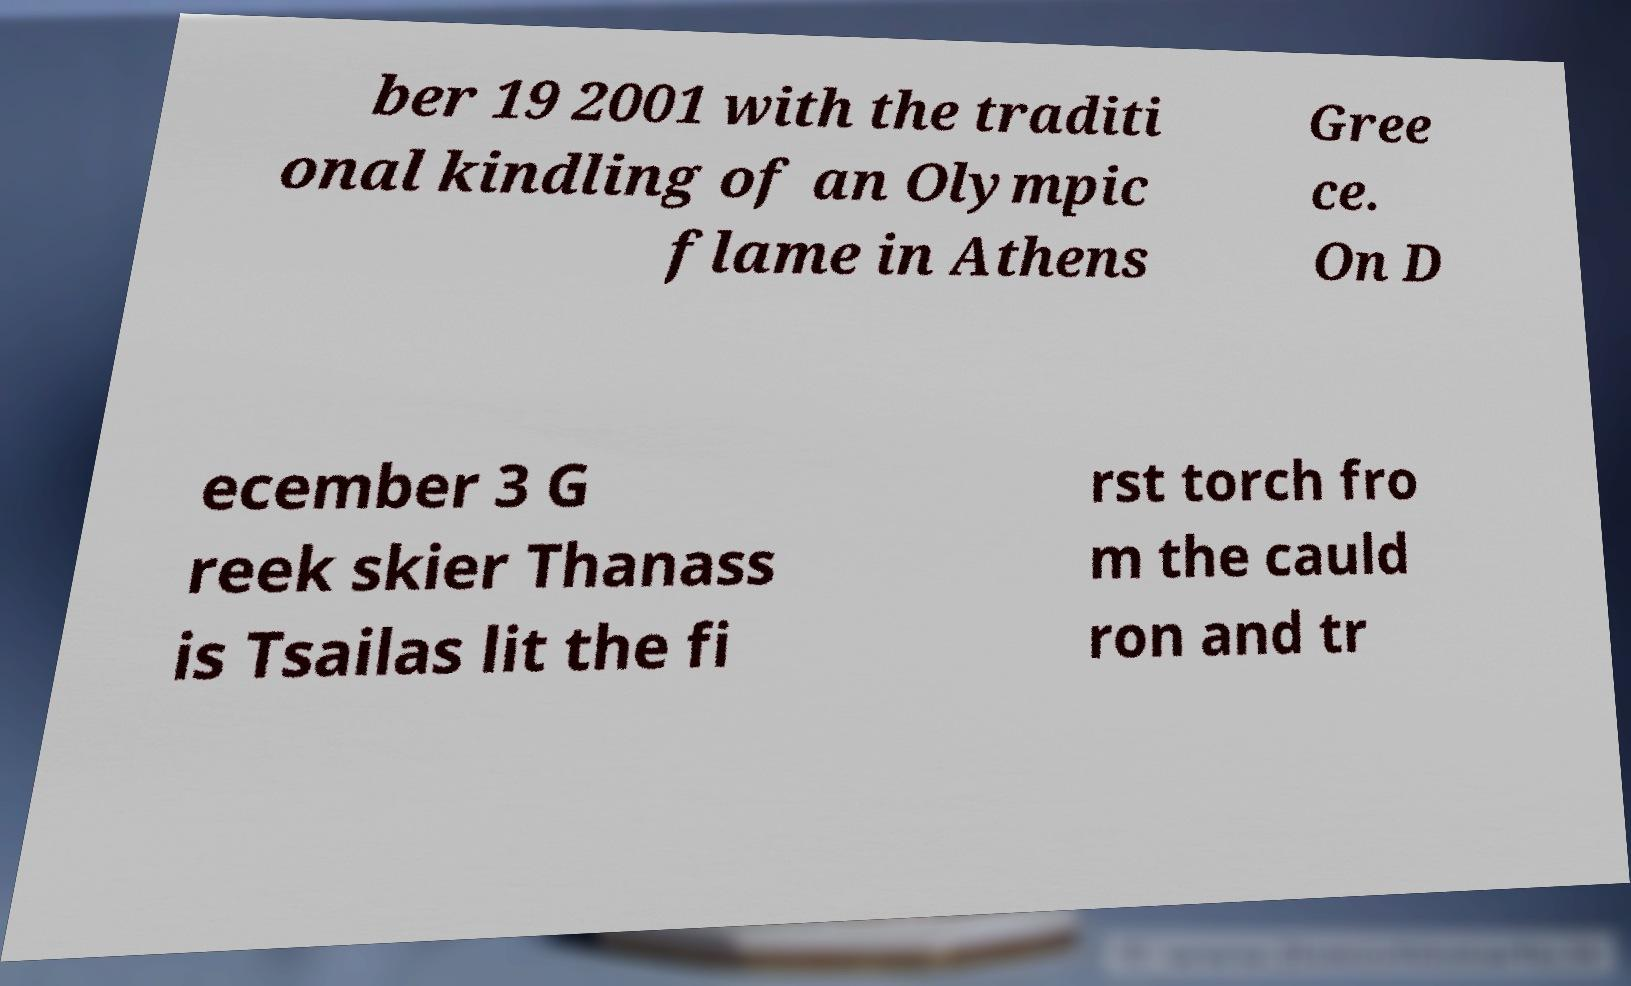For documentation purposes, I need the text within this image transcribed. Could you provide that? ber 19 2001 with the traditi onal kindling of an Olympic flame in Athens Gree ce. On D ecember 3 G reek skier Thanass is Tsailas lit the fi rst torch fro m the cauld ron and tr 